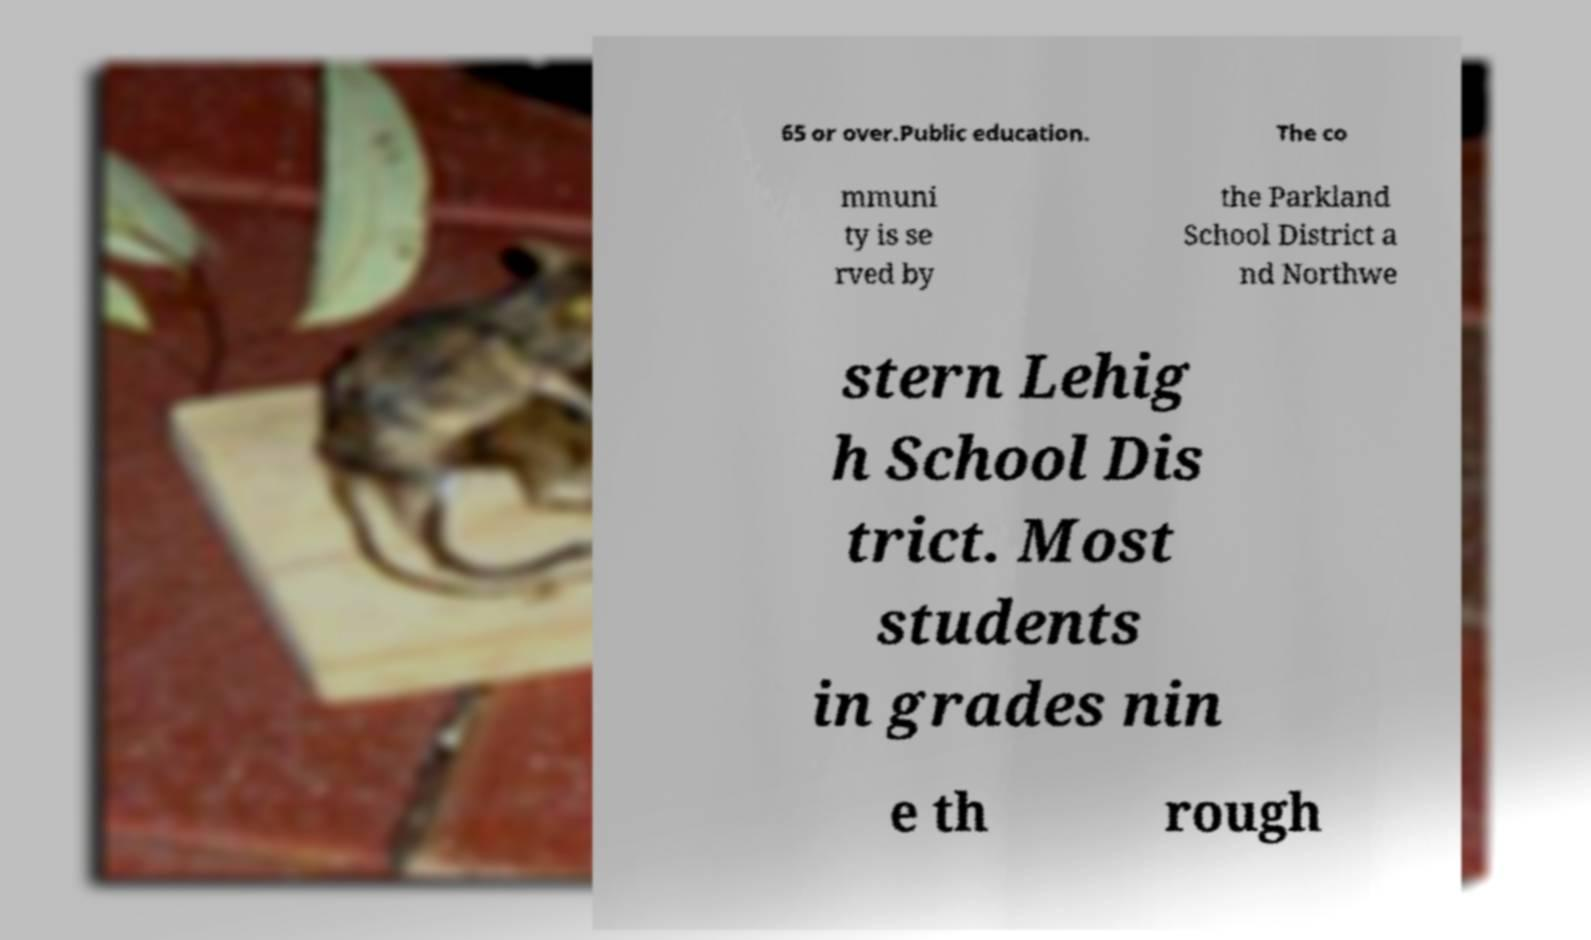Can you read and provide the text displayed in the image?This photo seems to have some interesting text. Can you extract and type it out for me? 65 or over.Public education. The co mmuni ty is se rved by the Parkland School District a nd Northwe stern Lehig h School Dis trict. Most students in grades nin e th rough 